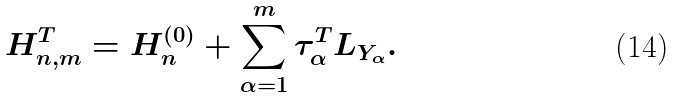Convert formula to latex. <formula><loc_0><loc_0><loc_500><loc_500>H _ { n , m } ^ { T } = H _ { n } ^ { ( 0 ) } + \sum _ { \alpha = 1 } ^ { m } \tau _ { \alpha } ^ { T } L _ { Y _ { \alpha } } .</formula> 